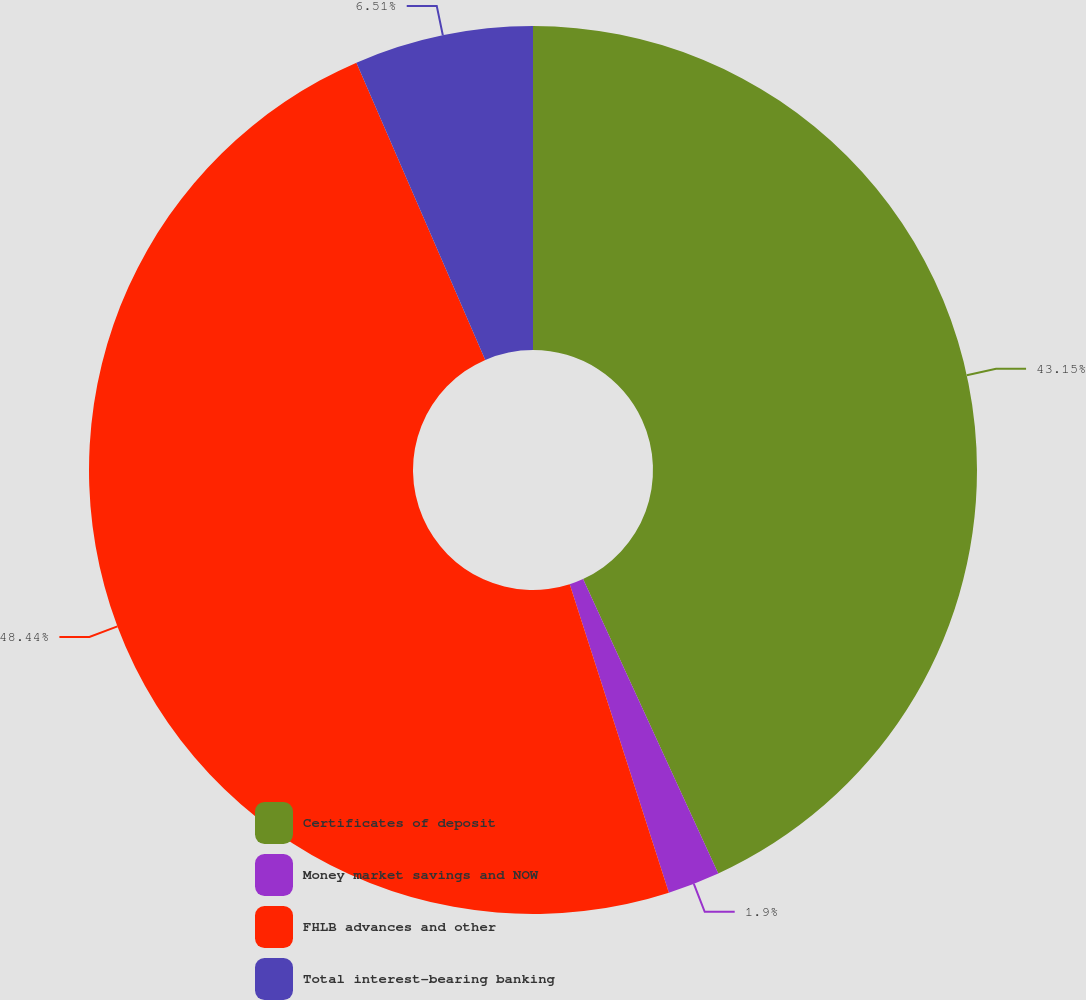Convert chart. <chart><loc_0><loc_0><loc_500><loc_500><pie_chart><fcel>Certificates of deposit<fcel>Money market savings and NOW<fcel>FHLB advances and other<fcel>Total interest-bearing banking<nl><fcel>43.15%<fcel>1.9%<fcel>48.44%<fcel>6.51%<nl></chart> 